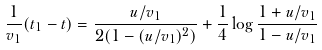Convert formula to latex. <formula><loc_0><loc_0><loc_500><loc_500>\frac { 1 } { v _ { 1 } } ( t _ { 1 } - t ) = \frac { u / v _ { 1 } } { 2 ( 1 - ( u / v _ { 1 } ) ^ { 2 } ) } + \frac { 1 } { 4 } \log \frac { 1 + u / v _ { 1 } } { 1 - u / v _ { 1 } }</formula> 